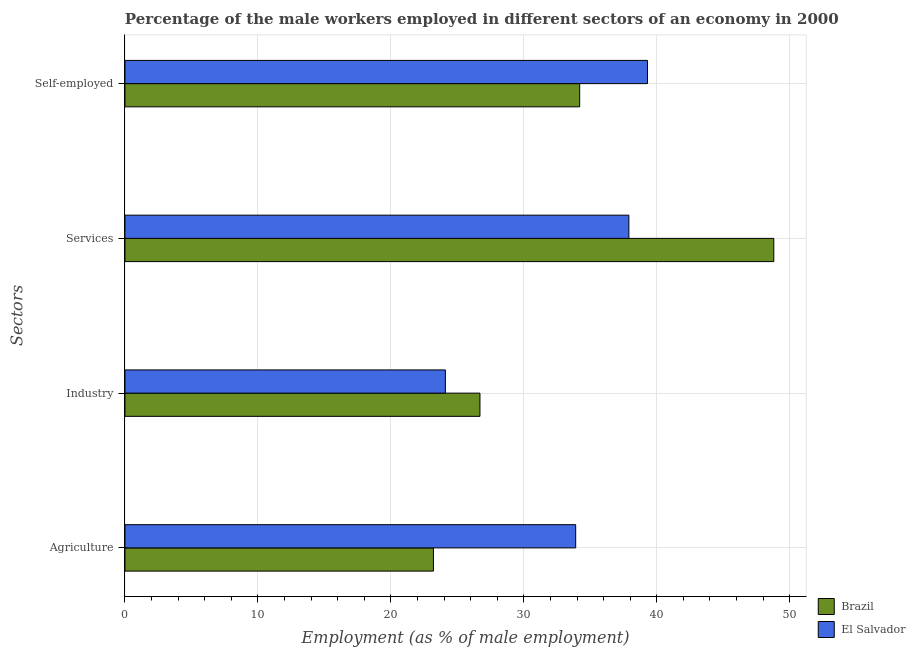How many groups of bars are there?
Ensure brevity in your answer.  4. Are the number of bars per tick equal to the number of legend labels?
Make the answer very short. Yes. Are the number of bars on each tick of the Y-axis equal?
Your answer should be compact. Yes. How many bars are there on the 4th tick from the bottom?
Your response must be concise. 2. What is the label of the 4th group of bars from the top?
Keep it short and to the point. Agriculture. What is the percentage of male workers in industry in Brazil?
Keep it short and to the point. 26.7. Across all countries, what is the maximum percentage of male workers in industry?
Offer a terse response. 26.7. Across all countries, what is the minimum percentage of male workers in services?
Your answer should be compact. 37.9. In which country was the percentage of male workers in services maximum?
Make the answer very short. Brazil. In which country was the percentage of male workers in services minimum?
Your answer should be compact. El Salvador. What is the total percentage of male workers in industry in the graph?
Give a very brief answer. 50.8. What is the difference between the percentage of male workers in agriculture in El Salvador and that in Brazil?
Provide a short and direct response. 10.7. What is the difference between the percentage of self employed male workers in El Salvador and the percentage of male workers in agriculture in Brazil?
Provide a succinct answer. 16.1. What is the average percentage of male workers in industry per country?
Your answer should be compact. 25.4. What is the difference between the percentage of self employed male workers and percentage of male workers in agriculture in Brazil?
Your answer should be compact. 11. What is the ratio of the percentage of male workers in services in El Salvador to that in Brazil?
Ensure brevity in your answer.  0.78. Is the percentage of male workers in services in El Salvador less than that in Brazil?
Your response must be concise. Yes. What is the difference between the highest and the second highest percentage of male workers in industry?
Give a very brief answer. 2.6. What is the difference between the highest and the lowest percentage of male workers in industry?
Ensure brevity in your answer.  2.6. Is it the case that in every country, the sum of the percentage of self employed male workers and percentage of male workers in services is greater than the sum of percentage of male workers in industry and percentage of male workers in agriculture?
Keep it short and to the point. Yes. What does the 1st bar from the top in Agriculture represents?
Offer a terse response. El Salvador. Is it the case that in every country, the sum of the percentage of male workers in agriculture and percentage of male workers in industry is greater than the percentage of male workers in services?
Give a very brief answer. Yes. Are all the bars in the graph horizontal?
Make the answer very short. Yes. Are the values on the major ticks of X-axis written in scientific E-notation?
Provide a short and direct response. No. Does the graph contain grids?
Offer a very short reply. Yes. What is the title of the graph?
Keep it short and to the point. Percentage of the male workers employed in different sectors of an economy in 2000. What is the label or title of the X-axis?
Offer a terse response. Employment (as % of male employment). What is the label or title of the Y-axis?
Your answer should be very brief. Sectors. What is the Employment (as % of male employment) of Brazil in Agriculture?
Your answer should be very brief. 23.2. What is the Employment (as % of male employment) in El Salvador in Agriculture?
Offer a terse response. 33.9. What is the Employment (as % of male employment) of Brazil in Industry?
Your answer should be compact. 26.7. What is the Employment (as % of male employment) of El Salvador in Industry?
Give a very brief answer. 24.1. What is the Employment (as % of male employment) of Brazil in Services?
Give a very brief answer. 48.8. What is the Employment (as % of male employment) of El Salvador in Services?
Your answer should be compact. 37.9. What is the Employment (as % of male employment) of Brazil in Self-employed?
Keep it short and to the point. 34.2. What is the Employment (as % of male employment) of El Salvador in Self-employed?
Your response must be concise. 39.3. Across all Sectors, what is the maximum Employment (as % of male employment) of Brazil?
Give a very brief answer. 48.8. Across all Sectors, what is the maximum Employment (as % of male employment) of El Salvador?
Offer a very short reply. 39.3. Across all Sectors, what is the minimum Employment (as % of male employment) in Brazil?
Offer a terse response. 23.2. Across all Sectors, what is the minimum Employment (as % of male employment) of El Salvador?
Offer a very short reply. 24.1. What is the total Employment (as % of male employment) in Brazil in the graph?
Your answer should be compact. 132.9. What is the total Employment (as % of male employment) of El Salvador in the graph?
Your response must be concise. 135.2. What is the difference between the Employment (as % of male employment) of Brazil in Agriculture and that in Industry?
Offer a very short reply. -3.5. What is the difference between the Employment (as % of male employment) in Brazil in Agriculture and that in Services?
Your answer should be very brief. -25.6. What is the difference between the Employment (as % of male employment) of El Salvador in Agriculture and that in Services?
Your response must be concise. -4. What is the difference between the Employment (as % of male employment) of Brazil in Agriculture and that in Self-employed?
Offer a very short reply. -11. What is the difference between the Employment (as % of male employment) of Brazil in Industry and that in Services?
Your response must be concise. -22.1. What is the difference between the Employment (as % of male employment) in El Salvador in Industry and that in Services?
Your answer should be compact. -13.8. What is the difference between the Employment (as % of male employment) of El Salvador in Industry and that in Self-employed?
Give a very brief answer. -15.2. What is the difference between the Employment (as % of male employment) in Brazil in Agriculture and the Employment (as % of male employment) in El Salvador in Industry?
Keep it short and to the point. -0.9. What is the difference between the Employment (as % of male employment) of Brazil in Agriculture and the Employment (as % of male employment) of El Salvador in Services?
Ensure brevity in your answer.  -14.7. What is the difference between the Employment (as % of male employment) of Brazil in Agriculture and the Employment (as % of male employment) of El Salvador in Self-employed?
Give a very brief answer. -16.1. What is the difference between the Employment (as % of male employment) in Brazil in Industry and the Employment (as % of male employment) in El Salvador in Self-employed?
Provide a short and direct response. -12.6. What is the average Employment (as % of male employment) of Brazil per Sectors?
Offer a very short reply. 33.23. What is the average Employment (as % of male employment) of El Salvador per Sectors?
Provide a succinct answer. 33.8. What is the difference between the Employment (as % of male employment) in Brazil and Employment (as % of male employment) in El Salvador in Self-employed?
Make the answer very short. -5.1. What is the ratio of the Employment (as % of male employment) in Brazil in Agriculture to that in Industry?
Your response must be concise. 0.87. What is the ratio of the Employment (as % of male employment) of El Salvador in Agriculture to that in Industry?
Keep it short and to the point. 1.41. What is the ratio of the Employment (as % of male employment) in Brazil in Agriculture to that in Services?
Ensure brevity in your answer.  0.48. What is the ratio of the Employment (as % of male employment) in El Salvador in Agriculture to that in Services?
Your answer should be compact. 0.89. What is the ratio of the Employment (as % of male employment) of Brazil in Agriculture to that in Self-employed?
Your answer should be compact. 0.68. What is the ratio of the Employment (as % of male employment) of El Salvador in Agriculture to that in Self-employed?
Make the answer very short. 0.86. What is the ratio of the Employment (as % of male employment) of Brazil in Industry to that in Services?
Provide a succinct answer. 0.55. What is the ratio of the Employment (as % of male employment) in El Salvador in Industry to that in Services?
Your response must be concise. 0.64. What is the ratio of the Employment (as % of male employment) of Brazil in Industry to that in Self-employed?
Give a very brief answer. 0.78. What is the ratio of the Employment (as % of male employment) in El Salvador in Industry to that in Self-employed?
Keep it short and to the point. 0.61. What is the ratio of the Employment (as % of male employment) in Brazil in Services to that in Self-employed?
Ensure brevity in your answer.  1.43. What is the ratio of the Employment (as % of male employment) of El Salvador in Services to that in Self-employed?
Offer a terse response. 0.96. What is the difference between the highest and the second highest Employment (as % of male employment) of El Salvador?
Give a very brief answer. 1.4. What is the difference between the highest and the lowest Employment (as % of male employment) in Brazil?
Offer a terse response. 25.6. 